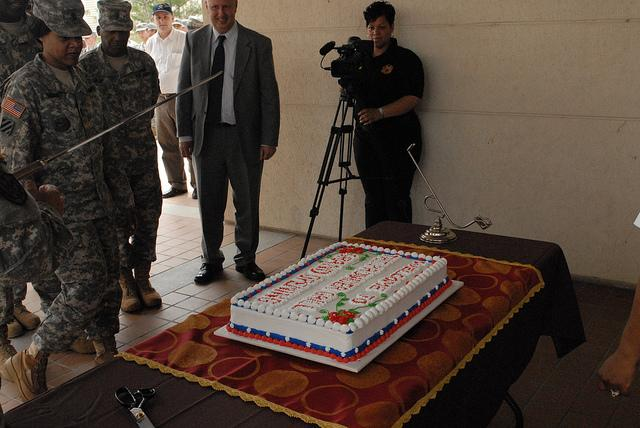What message does this cake send to those that see it? Please explain your reasoning. welcome. The word is written on it 